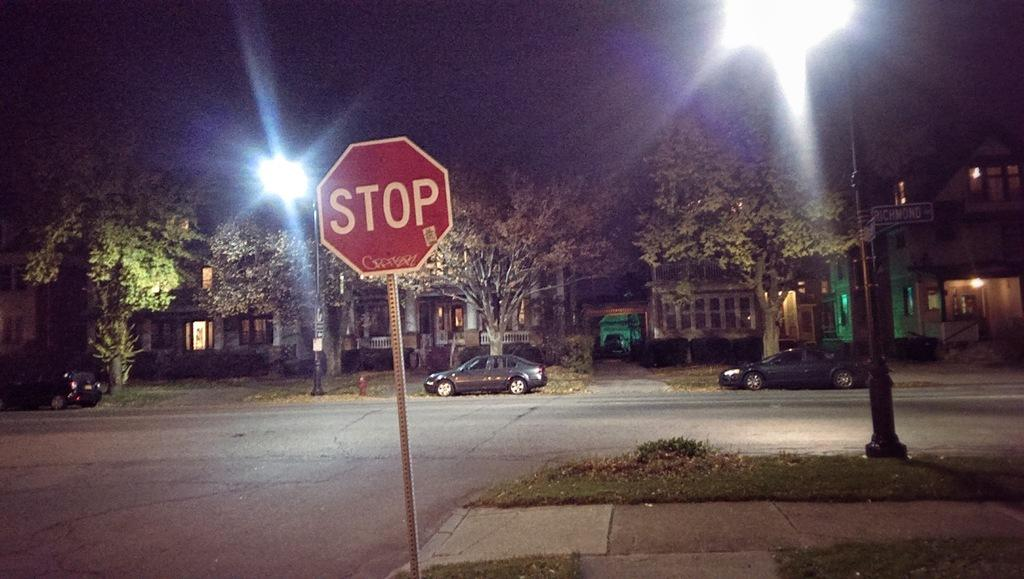Provide a one-sentence caption for the provided image. A stop sign stands on the edge of the road near the sidewalk. 